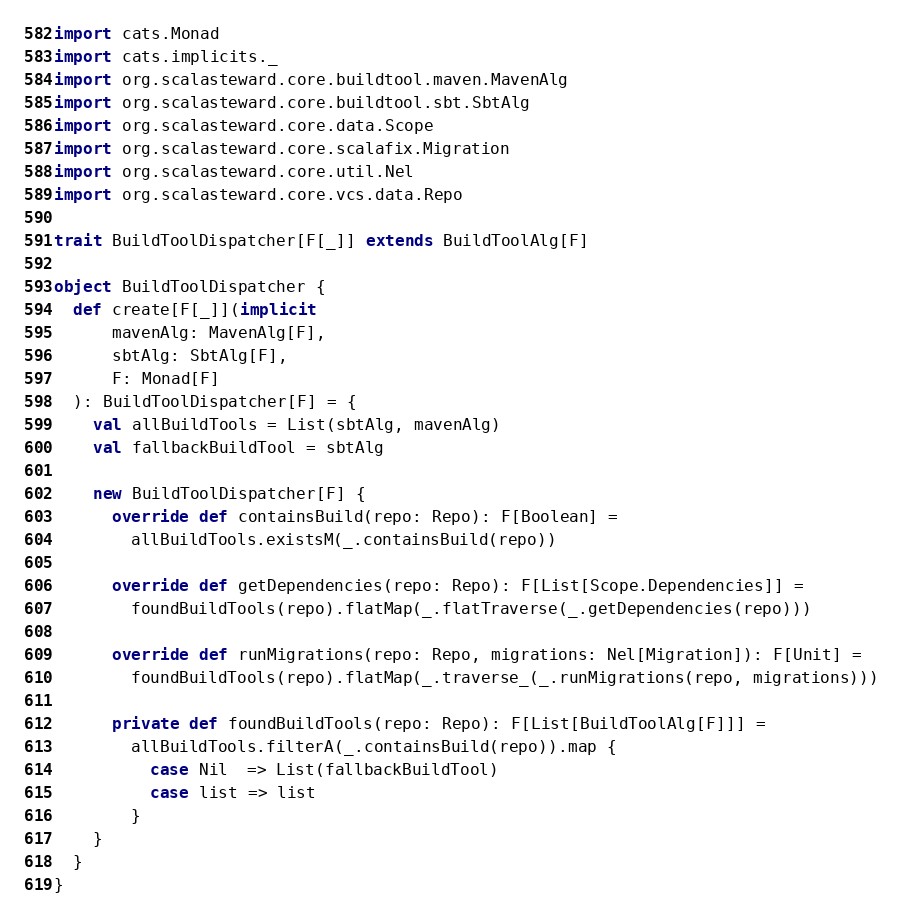Convert code to text. <code><loc_0><loc_0><loc_500><loc_500><_Scala_>
import cats.Monad
import cats.implicits._
import org.scalasteward.core.buildtool.maven.MavenAlg
import org.scalasteward.core.buildtool.sbt.SbtAlg
import org.scalasteward.core.data.Scope
import org.scalasteward.core.scalafix.Migration
import org.scalasteward.core.util.Nel
import org.scalasteward.core.vcs.data.Repo

trait BuildToolDispatcher[F[_]] extends BuildToolAlg[F]

object BuildToolDispatcher {
  def create[F[_]](implicit
      mavenAlg: MavenAlg[F],
      sbtAlg: SbtAlg[F],
      F: Monad[F]
  ): BuildToolDispatcher[F] = {
    val allBuildTools = List(sbtAlg, mavenAlg)
    val fallbackBuildTool = sbtAlg

    new BuildToolDispatcher[F] {
      override def containsBuild(repo: Repo): F[Boolean] =
        allBuildTools.existsM(_.containsBuild(repo))

      override def getDependencies(repo: Repo): F[List[Scope.Dependencies]] =
        foundBuildTools(repo).flatMap(_.flatTraverse(_.getDependencies(repo)))

      override def runMigrations(repo: Repo, migrations: Nel[Migration]): F[Unit] =
        foundBuildTools(repo).flatMap(_.traverse_(_.runMigrations(repo, migrations)))

      private def foundBuildTools(repo: Repo): F[List[BuildToolAlg[F]]] =
        allBuildTools.filterA(_.containsBuild(repo)).map {
          case Nil  => List(fallbackBuildTool)
          case list => list
        }
    }
  }
}
</code> 